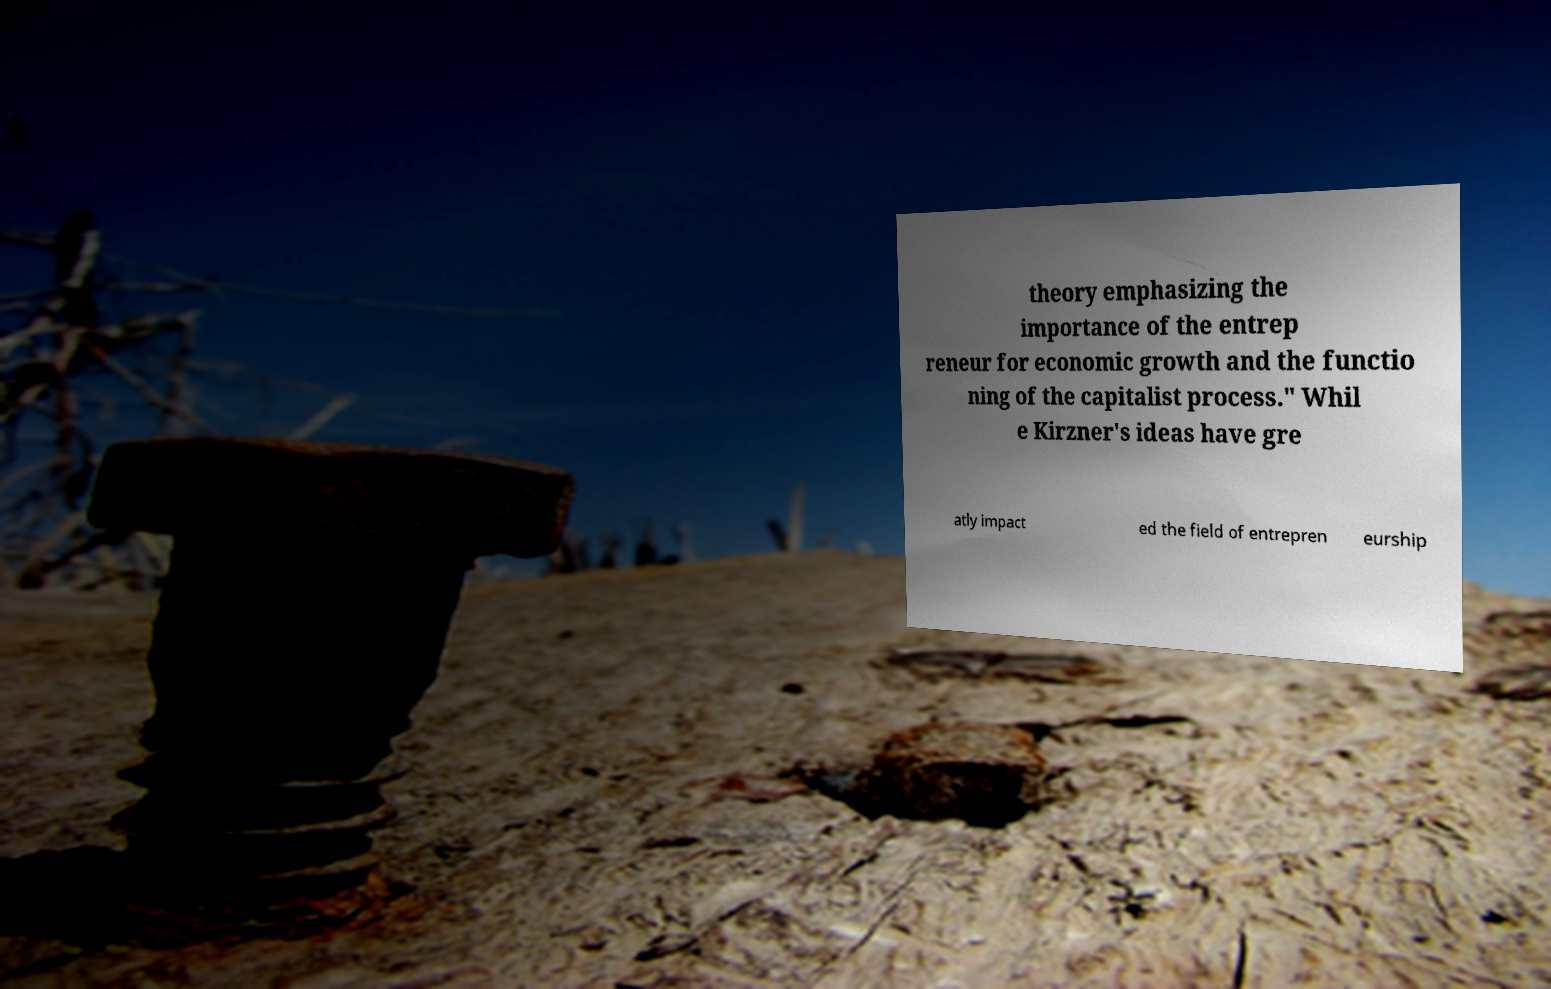There's text embedded in this image that I need extracted. Can you transcribe it verbatim? theory emphasizing the importance of the entrep reneur for economic growth and the functio ning of the capitalist process." Whil e Kirzner's ideas have gre atly impact ed the field of entrepren eurship 